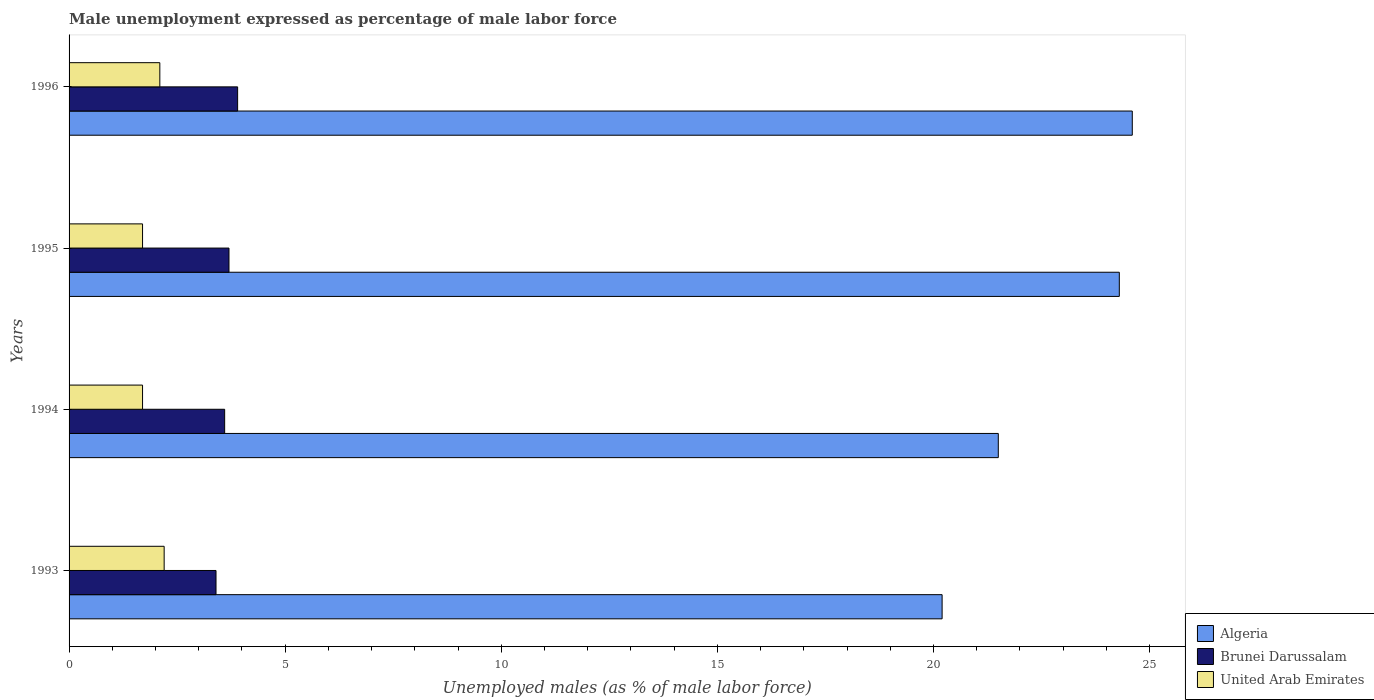Are the number of bars on each tick of the Y-axis equal?
Offer a very short reply. Yes. How many bars are there on the 1st tick from the top?
Your answer should be very brief. 3. How many bars are there on the 1st tick from the bottom?
Your answer should be compact. 3. What is the label of the 3rd group of bars from the top?
Give a very brief answer. 1994. What is the unemployment in males in in United Arab Emirates in 1994?
Give a very brief answer. 1.7. Across all years, what is the maximum unemployment in males in in Algeria?
Your answer should be compact. 24.6. Across all years, what is the minimum unemployment in males in in Brunei Darussalam?
Provide a short and direct response. 3.4. In which year was the unemployment in males in in United Arab Emirates maximum?
Give a very brief answer. 1993. What is the total unemployment in males in in Algeria in the graph?
Give a very brief answer. 90.6. What is the difference between the unemployment in males in in Algeria in 1994 and that in 1995?
Your response must be concise. -2.8. What is the difference between the unemployment in males in in Algeria in 1993 and the unemployment in males in in Brunei Darussalam in 1995?
Offer a terse response. 16.5. What is the average unemployment in males in in Brunei Darussalam per year?
Your response must be concise. 3.65. In the year 1993, what is the difference between the unemployment in males in in Brunei Darussalam and unemployment in males in in Algeria?
Provide a short and direct response. -16.8. What is the ratio of the unemployment in males in in United Arab Emirates in 1995 to that in 1996?
Offer a very short reply. 0.81. Is the difference between the unemployment in males in in Brunei Darussalam in 1994 and 1995 greater than the difference between the unemployment in males in in Algeria in 1994 and 1995?
Offer a terse response. Yes. What is the difference between the highest and the second highest unemployment in males in in Brunei Darussalam?
Provide a short and direct response. 0.2. Is the sum of the unemployment in males in in Algeria in 1993 and 1994 greater than the maximum unemployment in males in in Brunei Darussalam across all years?
Keep it short and to the point. Yes. What does the 2nd bar from the top in 1996 represents?
Provide a short and direct response. Brunei Darussalam. What does the 2nd bar from the bottom in 1996 represents?
Make the answer very short. Brunei Darussalam. Is it the case that in every year, the sum of the unemployment in males in in United Arab Emirates and unemployment in males in in Brunei Darussalam is greater than the unemployment in males in in Algeria?
Provide a short and direct response. No. How many years are there in the graph?
Your response must be concise. 4. What is the difference between two consecutive major ticks on the X-axis?
Offer a terse response. 5. Does the graph contain grids?
Provide a short and direct response. No. How many legend labels are there?
Give a very brief answer. 3. What is the title of the graph?
Provide a short and direct response. Male unemployment expressed as percentage of male labor force. What is the label or title of the X-axis?
Provide a short and direct response. Unemployed males (as % of male labor force). What is the Unemployed males (as % of male labor force) in Algeria in 1993?
Make the answer very short. 20.2. What is the Unemployed males (as % of male labor force) of Brunei Darussalam in 1993?
Your response must be concise. 3.4. What is the Unemployed males (as % of male labor force) in United Arab Emirates in 1993?
Offer a terse response. 2.2. What is the Unemployed males (as % of male labor force) in Algeria in 1994?
Keep it short and to the point. 21.5. What is the Unemployed males (as % of male labor force) in Brunei Darussalam in 1994?
Offer a very short reply. 3.6. What is the Unemployed males (as % of male labor force) of United Arab Emirates in 1994?
Your answer should be compact. 1.7. What is the Unemployed males (as % of male labor force) of Algeria in 1995?
Make the answer very short. 24.3. What is the Unemployed males (as % of male labor force) in Brunei Darussalam in 1995?
Your answer should be very brief. 3.7. What is the Unemployed males (as % of male labor force) of United Arab Emirates in 1995?
Provide a short and direct response. 1.7. What is the Unemployed males (as % of male labor force) in Algeria in 1996?
Make the answer very short. 24.6. What is the Unemployed males (as % of male labor force) in Brunei Darussalam in 1996?
Your answer should be very brief. 3.9. What is the Unemployed males (as % of male labor force) of United Arab Emirates in 1996?
Give a very brief answer. 2.1. Across all years, what is the maximum Unemployed males (as % of male labor force) in Algeria?
Your answer should be compact. 24.6. Across all years, what is the maximum Unemployed males (as % of male labor force) in Brunei Darussalam?
Ensure brevity in your answer.  3.9. Across all years, what is the maximum Unemployed males (as % of male labor force) of United Arab Emirates?
Offer a very short reply. 2.2. Across all years, what is the minimum Unemployed males (as % of male labor force) of Algeria?
Provide a succinct answer. 20.2. Across all years, what is the minimum Unemployed males (as % of male labor force) in Brunei Darussalam?
Offer a terse response. 3.4. Across all years, what is the minimum Unemployed males (as % of male labor force) of United Arab Emirates?
Offer a very short reply. 1.7. What is the total Unemployed males (as % of male labor force) in Algeria in the graph?
Provide a short and direct response. 90.6. What is the difference between the Unemployed males (as % of male labor force) of Algeria in 1993 and that in 1994?
Provide a succinct answer. -1.3. What is the difference between the Unemployed males (as % of male labor force) of United Arab Emirates in 1993 and that in 1994?
Offer a very short reply. 0.5. What is the difference between the Unemployed males (as % of male labor force) of Algeria in 1993 and that in 1995?
Ensure brevity in your answer.  -4.1. What is the difference between the Unemployed males (as % of male labor force) in United Arab Emirates in 1993 and that in 1995?
Your response must be concise. 0.5. What is the difference between the Unemployed males (as % of male labor force) of Algeria in 1993 and that in 1996?
Ensure brevity in your answer.  -4.4. What is the difference between the Unemployed males (as % of male labor force) in United Arab Emirates in 1993 and that in 1996?
Offer a terse response. 0.1. What is the difference between the Unemployed males (as % of male labor force) of Algeria in 1994 and that in 1995?
Ensure brevity in your answer.  -2.8. What is the difference between the Unemployed males (as % of male labor force) of United Arab Emirates in 1994 and that in 1995?
Provide a short and direct response. 0. What is the difference between the Unemployed males (as % of male labor force) of Brunei Darussalam in 1994 and that in 1996?
Offer a terse response. -0.3. What is the difference between the Unemployed males (as % of male labor force) in United Arab Emirates in 1994 and that in 1996?
Your answer should be very brief. -0.4. What is the difference between the Unemployed males (as % of male labor force) of Brunei Darussalam in 1995 and that in 1996?
Offer a terse response. -0.2. What is the difference between the Unemployed males (as % of male labor force) in Brunei Darussalam in 1993 and the Unemployed males (as % of male labor force) in United Arab Emirates in 1994?
Offer a terse response. 1.7. What is the difference between the Unemployed males (as % of male labor force) in Algeria in 1994 and the Unemployed males (as % of male labor force) in United Arab Emirates in 1995?
Provide a succinct answer. 19.8. What is the difference between the Unemployed males (as % of male labor force) in Brunei Darussalam in 1994 and the Unemployed males (as % of male labor force) in United Arab Emirates in 1995?
Give a very brief answer. 1.9. What is the difference between the Unemployed males (as % of male labor force) in Brunei Darussalam in 1994 and the Unemployed males (as % of male labor force) in United Arab Emirates in 1996?
Your response must be concise. 1.5. What is the difference between the Unemployed males (as % of male labor force) of Algeria in 1995 and the Unemployed males (as % of male labor force) of Brunei Darussalam in 1996?
Your answer should be compact. 20.4. What is the difference between the Unemployed males (as % of male labor force) in Algeria in 1995 and the Unemployed males (as % of male labor force) in United Arab Emirates in 1996?
Keep it short and to the point. 22.2. What is the difference between the Unemployed males (as % of male labor force) of Brunei Darussalam in 1995 and the Unemployed males (as % of male labor force) of United Arab Emirates in 1996?
Your answer should be very brief. 1.6. What is the average Unemployed males (as % of male labor force) in Algeria per year?
Your answer should be very brief. 22.65. What is the average Unemployed males (as % of male labor force) of Brunei Darussalam per year?
Ensure brevity in your answer.  3.65. What is the average Unemployed males (as % of male labor force) of United Arab Emirates per year?
Your answer should be very brief. 1.93. In the year 1993, what is the difference between the Unemployed males (as % of male labor force) in Algeria and Unemployed males (as % of male labor force) in United Arab Emirates?
Offer a terse response. 18. In the year 1994, what is the difference between the Unemployed males (as % of male labor force) in Algeria and Unemployed males (as % of male labor force) in Brunei Darussalam?
Provide a succinct answer. 17.9. In the year 1994, what is the difference between the Unemployed males (as % of male labor force) of Algeria and Unemployed males (as % of male labor force) of United Arab Emirates?
Provide a short and direct response. 19.8. In the year 1994, what is the difference between the Unemployed males (as % of male labor force) in Brunei Darussalam and Unemployed males (as % of male labor force) in United Arab Emirates?
Make the answer very short. 1.9. In the year 1995, what is the difference between the Unemployed males (as % of male labor force) in Algeria and Unemployed males (as % of male labor force) in Brunei Darussalam?
Provide a succinct answer. 20.6. In the year 1995, what is the difference between the Unemployed males (as % of male labor force) in Algeria and Unemployed males (as % of male labor force) in United Arab Emirates?
Your answer should be compact. 22.6. In the year 1995, what is the difference between the Unemployed males (as % of male labor force) of Brunei Darussalam and Unemployed males (as % of male labor force) of United Arab Emirates?
Provide a short and direct response. 2. In the year 1996, what is the difference between the Unemployed males (as % of male labor force) in Algeria and Unemployed males (as % of male labor force) in Brunei Darussalam?
Keep it short and to the point. 20.7. In the year 1996, what is the difference between the Unemployed males (as % of male labor force) of Brunei Darussalam and Unemployed males (as % of male labor force) of United Arab Emirates?
Provide a succinct answer. 1.8. What is the ratio of the Unemployed males (as % of male labor force) of Algeria in 1993 to that in 1994?
Provide a succinct answer. 0.94. What is the ratio of the Unemployed males (as % of male labor force) in United Arab Emirates in 1993 to that in 1994?
Ensure brevity in your answer.  1.29. What is the ratio of the Unemployed males (as % of male labor force) of Algeria in 1993 to that in 1995?
Your answer should be very brief. 0.83. What is the ratio of the Unemployed males (as % of male labor force) of Brunei Darussalam in 1993 to that in 1995?
Offer a terse response. 0.92. What is the ratio of the Unemployed males (as % of male labor force) in United Arab Emirates in 1993 to that in 1995?
Ensure brevity in your answer.  1.29. What is the ratio of the Unemployed males (as % of male labor force) of Algeria in 1993 to that in 1996?
Keep it short and to the point. 0.82. What is the ratio of the Unemployed males (as % of male labor force) of Brunei Darussalam in 1993 to that in 1996?
Offer a very short reply. 0.87. What is the ratio of the Unemployed males (as % of male labor force) in United Arab Emirates in 1993 to that in 1996?
Offer a very short reply. 1.05. What is the ratio of the Unemployed males (as % of male labor force) in Algeria in 1994 to that in 1995?
Offer a terse response. 0.88. What is the ratio of the Unemployed males (as % of male labor force) in Brunei Darussalam in 1994 to that in 1995?
Ensure brevity in your answer.  0.97. What is the ratio of the Unemployed males (as % of male labor force) of Algeria in 1994 to that in 1996?
Give a very brief answer. 0.87. What is the ratio of the Unemployed males (as % of male labor force) in Brunei Darussalam in 1994 to that in 1996?
Offer a terse response. 0.92. What is the ratio of the Unemployed males (as % of male labor force) of United Arab Emirates in 1994 to that in 1996?
Your response must be concise. 0.81. What is the ratio of the Unemployed males (as % of male labor force) of Algeria in 1995 to that in 1996?
Offer a very short reply. 0.99. What is the ratio of the Unemployed males (as % of male labor force) in Brunei Darussalam in 1995 to that in 1996?
Give a very brief answer. 0.95. What is the ratio of the Unemployed males (as % of male labor force) in United Arab Emirates in 1995 to that in 1996?
Ensure brevity in your answer.  0.81. What is the difference between the highest and the second highest Unemployed males (as % of male labor force) in Brunei Darussalam?
Ensure brevity in your answer.  0.2. What is the difference between the highest and the second highest Unemployed males (as % of male labor force) in United Arab Emirates?
Offer a terse response. 0.1. What is the difference between the highest and the lowest Unemployed males (as % of male labor force) of Algeria?
Make the answer very short. 4.4. What is the difference between the highest and the lowest Unemployed males (as % of male labor force) of Brunei Darussalam?
Provide a succinct answer. 0.5. 